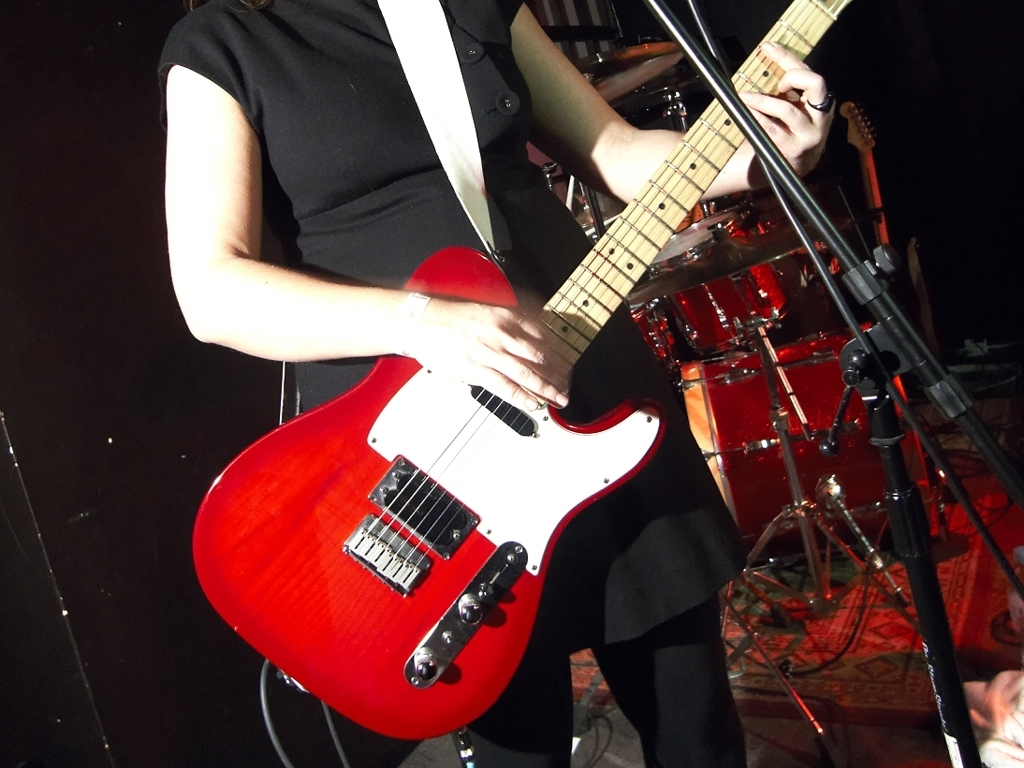Is there strong lighting in the image?
 Yes 